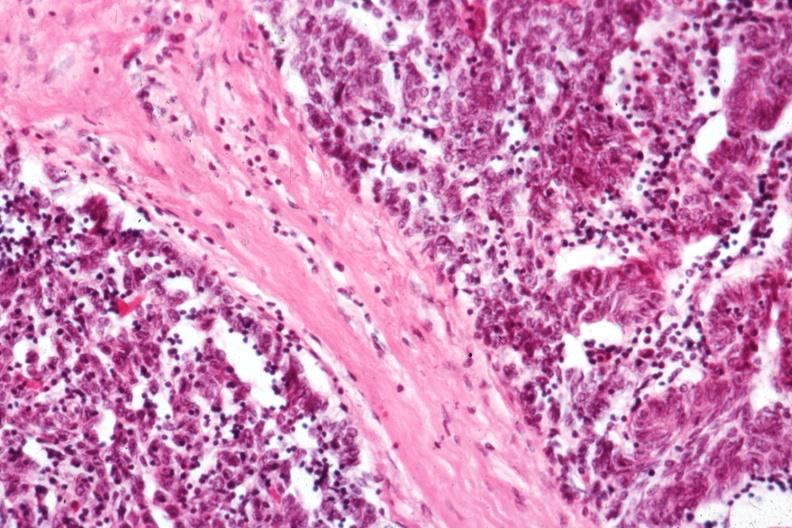what is present?
Answer the question using a single word or phrase. Thymoma 